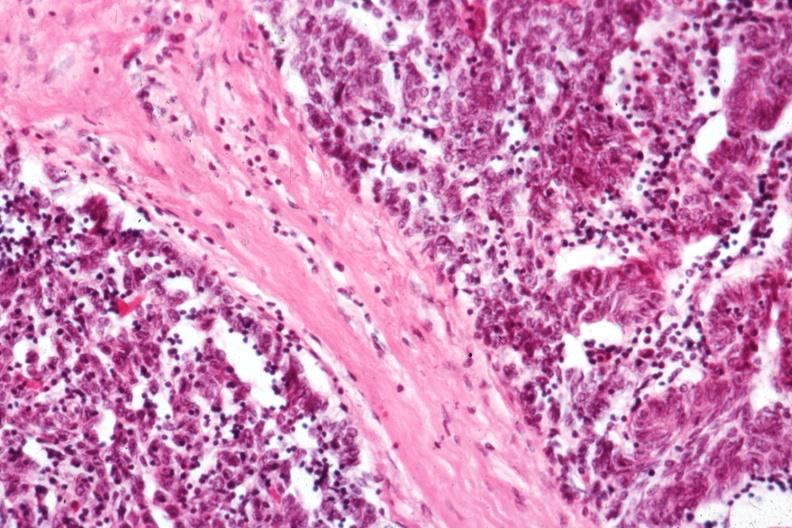what is present?
Answer the question using a single word or phrase. Thymoma 